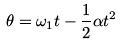Convert formula to latex. <formula><loc_0><loc_0><loc_500><loc_500>\theta = \omega _ { 1 } t - \frac { 1 } { 2 } \alpha t ^ { 2 }</formula> 